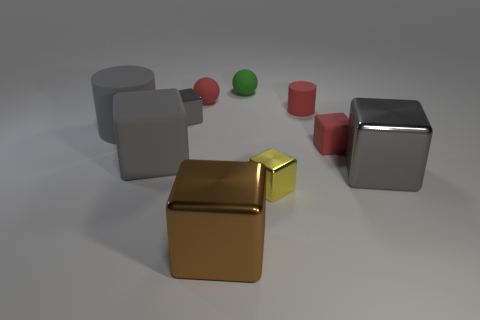Subtract all blue balls. How many gray cubes are left? 3 Subtract all brown cubes. How many cubes are left? 5 Subtract all tiny red rubber cubes. How many cubes are left? 5 Subtract all purple blocks. Subtract all yellow cylinders. How many blocks are left? 6 Subtract all balls. How many objects are left? 8 Add 1 green matte balls. How many green matte balls exist? 2 Subtract 0 cyan cubes. How many objects are left? 10 Subtract all gray shiny things. Subtract all large cyan metal things. How many objects are left? 8 Add 7 gray rubber objects. How many gray rubber objects are left? 9 